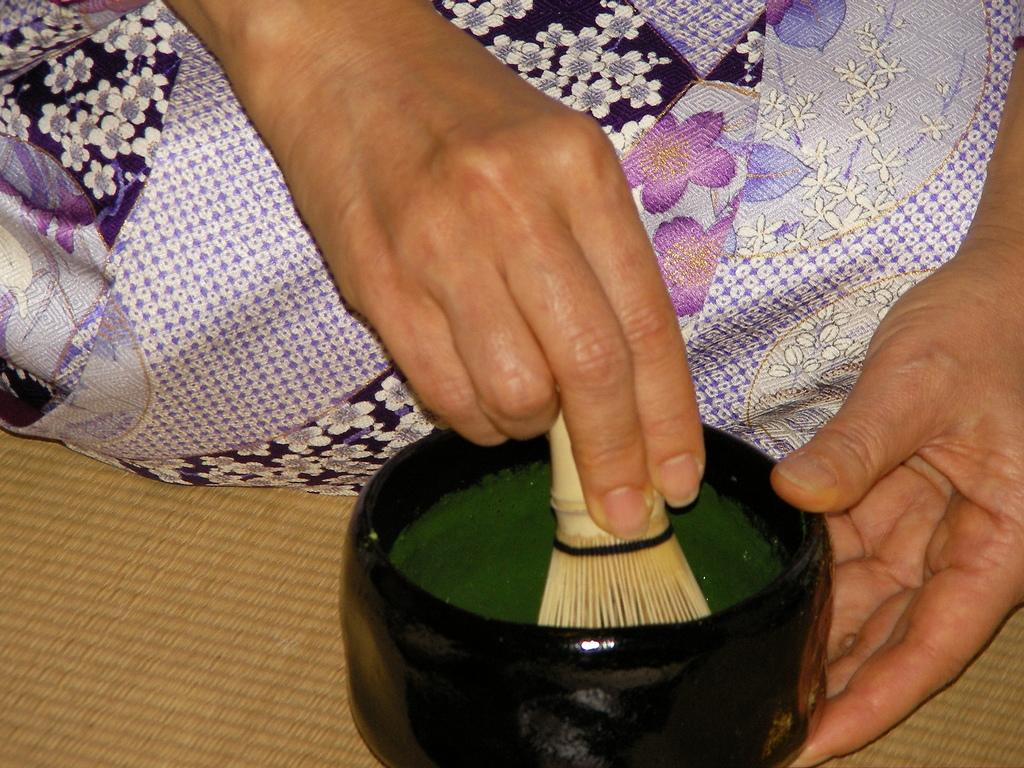What can be seen in the image involving hands? There are hands in the image that are mixing green color. What color is being mixed in the image? The hands are mixing green color. What type of container is holding the green color? The green color is in a black bowl. What tool is being used for mixing the color? A brush is being used for mixing. What type of loaf is being prepared in the image? There is no loaf being prepared in the image; it features hands mixing green color in a black bowl using a brush. 